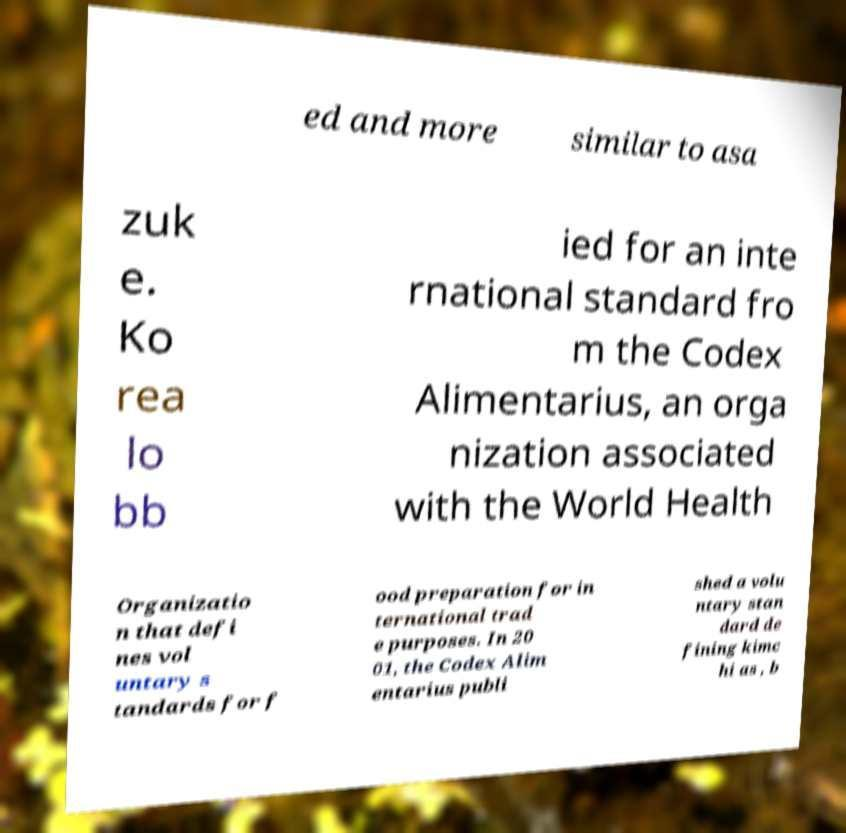I need the written content from this picture converted into text. Can you do that? ed and more similar to asa zuk e. Ko rea lo bb ied for an inte rnational standard fro m the Codex Alimentarius, an orga nization associated with the World Health Organizatio n that defi nes vol untary s tandards for f ood preparation for in ternational trad e purposes. In 20 01, the Codex Alim entarius publi shed a volu ntary stan dard de fining kimc hi as , b 